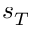<formula> <loc_0><loc_0><loc_500><loc_500>s _ { T }</formula> 